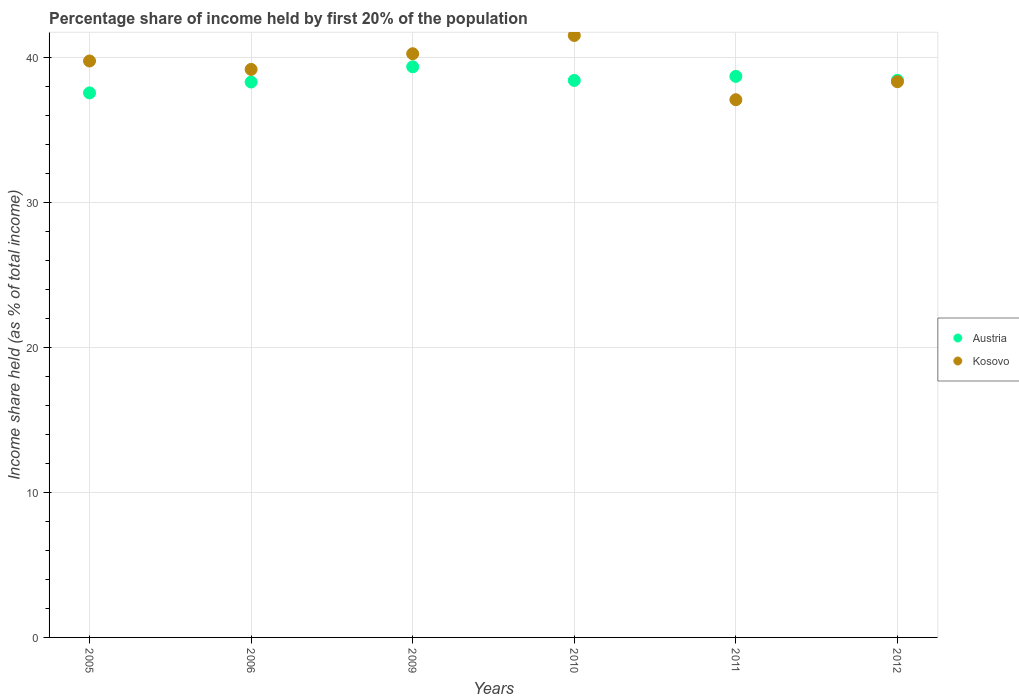Is the number of dotlines equal to the number of legend labels?
Make the answer very short. Yes. What is the share of income held by first 20% of the population in Austria in 2010?
Offer a terse response. 38.4. Across all years, what is the maximum share of income held by first 20% of the population in Kosovo?
Your answer should be compact. 41.5. Across all years, what is the minimum share of income held by first 20% of the population in Austria?
Your answer should be compact. 37.54. In which year was the share of income held by first 20% of the population in Austria maximum?
Give a very brief answer. 2009. In which year was the share of income held by first 20% of the population in Kosovo minimum?
Your response must be concise. 2011. What is the total share of income held by first 20% of the population in Kosovo in the graph?
Offer a very short reply. 236.02. What is the difference between the share of income held by first 20% of the population in Austria in 2006 and that in 2012?
Make the answer very short. -0.12. What is the difference between the share of income held by first 20% of the population in Kosovo in 2009 and the share of income held by first 20% of the population in Austria in 2012?
Make the answer very short. 1.83. What is the average share of income held by first 20% of the population in Austria per year?
Keep it short and to the point. 38.44. In the year 2005, what is the difference between the share of income held by first 20% of the population in Kosovo and share of income held by first 20% of the population in Austria?
Make the answer very short. 2.2. What is the ratio of the share of income held by first 20% of the population in Kosovo in 2005 to that in 2012?
Your answer should be very brief. 1.04. Is the share of income held by first 20% of the population in Austria in 2005 less than that in 2011?
Offer a terse response. Yes. What is the difference between the highest and the second highest share of income held by first 20% of the population in Kosovo?
Offer a very short reply. 1.26. What is the difference between the highest and the lowest share of income held by first 20% of the population in Kosovo?
Your answer should be very brief. 4.43. Is the sum of the share of income held by first 20% of the population in Kosovo in 2009 and 2011 greater than the maximum share of income held by first 20% of the population in Austria across all years?
Provide a succinct answer. Yes. Is the share of income held by first 20% of the population in Austria strictly greater than the share of income held by first 20% of the population in Kosovo over the years?
Your response must be concise. No. Is the share of income held by first 20% of the population in Kosovo strictly less than the share of income held by first 20% of the population in Austria over the years?
Provide a short and direct response. No. How many dotlines are there?
Ensure brevity in your answer.  2. Where does the legend appear in the graph?
Provide a short and direct response. Center right. How are the legend labels stacked?
Offer a terse response. Vertical. What is the title of the graph?
Offer a terse response. Percentage share of income held by first 20% of the population. Does "South Asia" appear as one of the legend labels in the graph?
Offer a very short reply. No. What is the label or title of the Y-axis?
Offer a terse response. Income share held (as % of total income). What is the Income share held (as % of total income) in Austria in 2005?
Make the answer very short. 37.54. What is the Income share held (as % of total income) of Kosovo in 2005?
Your answer should be very brief. 39.74. What is the Income share held (as % of total income) of Austria in 2006?
Your answer should be very brief. 38.29. What is the Income share held (as % of total income) in Kosovo in 2006?
Provide a short and direct response. 39.16. What is the Income share held (as % of total income) of Austria in 2009?
Provide a short and direct response. 39.34. What is the Income share held (as % of total income) in Kosovo in 2009?
Offer a terse response. 40.24. What is the Income share held (as % of total income) of Austria in 2010?
Provide a short and direct response. 38.4. What is the Income share held (as % of total income) in Kosovo in 2010?
Your response must be concise. 41.5. What is the Income share held (as % of total income) of Austria in 2011?
Make the answer very short. 38.68. What is the Income share held (as % of total income) of Kosovo in 2011?
Ensure brevity in your answer.  37.07. What is the Income share held (as % of total income) of Austria in 2012?
Offer a terse response. 38.41. What is the Income share held (as % of total income) of Kosovo in 2012?
Keep it short and to the point. 38.31. Across all years, what is the maximum Income share held (as % of total income) in Austria?
Provide a short and direct response. 39.34. Across all years, what is the maximum Income share held (as % of total income) in Kosovo?
Offer a very short reply. 41.5. Across all years, what is the minimum Income share held (as % of total income) of Austria?
Make the answer very short. 37.54. Across all years, what is the minimum Income share held (as % of total income) of Kosovo?
Your response must be concise. 37.07. What is the total Income share held (as % of total income) in Austria in the graph?
Offer a terse response. 230.66. What is the total Income share held (as % of total income) of Kosovo in the graph?
Offer a very short reply. 236.02. What is the difference between the Income share held (as % of total income) in Austria in 2005 and that in 2006?
Ensure brevity in your answer.  -0.75. What is the difference between the Income share held (as % of total income) of Kosovo in 2005 and that in 2006?
Offer a terse response. 0.58. What is the difference between the Income share held (as % of total income) in Austria in 2005 and that in 2009?
Keep it short and to the point. -1.8. What is the difference between the Income share held (as % of total income) of Austria in 2005 and that in 2010?
Your answer should be compact. -0.86. What is the difference between the Income share held (as % of total income) of Kosovo in 2005 and that in 2010?
Your answer should be compact. -1.76. What is the difference between the Income share held (as % of total income) in Austria in 2005 and that in 2011?
Keep it short and to the point. -1.14. What is the difference between the Income share held (as % of total income) in Kosovo in 2005 and that in 2011?
Provide a short and direct response. 2.67. What is the difference between the Income share held (as % of total income) in Austria in 2005 and that in 2012?
Provide a short and direct response. -0.87. What is the difference between the Income share held (as % of total income) in Kosovo in 2005 and that in 2012?
Your answer should be very brief. 1.43. What is the difference between the Income share held (as % of total income) in Austria in 2006 and that in 2009?
Make the answer very short. -1.05. What is the difference between the Income share held (as % of total income) in Kosovo in 2006 and that in 2009?
Keep it short and to the point. -1.08. What is the difference between the Income share held (as % of total income) of Austria in 2006 and that in 2010?
Offer a very short reply. -0.11. What is the difference between the Income share held (as % of total income) of Kosovo in 2006 and that in 2010?
Your answer should be compact. -2.34. What is the difference between the Income share held (as % of total income) in Austria in 2006 and that in 2011?
Offer a very short reply. -0.39. What is the difference between the Income share held (as % of total income) in Kosovo in 2006 and that in 2011?
Ensure brevity in your answer.  2.09. What is the difference between the Income share held (as % of total income) of Austria in 2006 and that in 2012?
Your answer should be very brief. -0.12. What is the difference between the Income share held (as % of total income) of Austria in 2009 and that in 2010?
Provide a succinct answer. 0.94. What is the difference between the Income share held (as % of total income) in Kosovo in 2009 and that in 2010?
Provide a succinct answer. -1.26. What is the difference between the Income share held (as % of total income) in Austria in 2009 and that in 2011?
Offer a terse response. 0.66. What is the difference between the Income share held (as % of total income) of Kosovo in 2009 and that in 2011?
Offer a very short reply. 3.17. What is the difference between the Income share held (as % of total income) of Kosovo in 2009 and that in 2012?
Give a very brief answer. 1.93. What is the difference between the Income share held (as % of total income) in Austria in 2010 and that in 2011?
Provide a succinct answer. -0.28. What is the difference between the Income share held (as % of total income) of Kosovo in 2010 and that in 2011?
Make the answer very short. 4.43. What is the difference between the Income share held (as % of total income) in Austria in 2010 and that in 2012?
Provide a short and direct response. -0.01. What is the difference between the Income share held (as % of total income) in Kosovo in 2010 and that in 2012?
Your answer should be very brief. 3.19. What is the difference between the Income share held (as % of total income) in Austria in 2011 and that in 2012?
Provide a short and direct response. 0.27. What is the difference between the Income share held (as % of total income) of Kosovo in 2011 and that in 2012?
Your answer should be very brief. -1.24. What is the difference between the Income share held (as % of total income) of Austria in 2005 and the Income share held (as % of total income) of Kosovo in 2006?
Offer a very short reply. -1.62. What is the difference between the Income share held (as % of total income) in Austria in 2005 and the Income share held (as % of total income) in Kosovo in 2009?
Your response must be concise. -2.7. What is the difference between the Income share held (as % of total income) in Austria in 2005 and the Income share held (as % of total income) in Kosovo in 2010?
Offer a very short reply. -3.96. What is the difference between the Income share held (as % of total income) in Austria in 2005 and the Income share held (as % of total income) in Kosovo in 2011?
Ensure brevity in your answer.  0.47. What is the difference between the Income share held (as % of total income) of Austria in 2005 and the Income share held (as % of total income) of Kosovo in 2012?
Offer a very short reply. -0.77. What is the difference between the Income share held (as % of total income) in Austria in 2006 and the Income share held (as % of total income) in Kosovo in 2009?
Offer a terse response. -1.95. What is the difference between the Income share held (as % of total income) of Austria in 2006 and the Income share held (as % of total income) of Kosovo in 2010?
Your response must be concise. -3.21. What is the difference between the Income share held (as % of total income) in Austria in 2006 and the Income share held (as % of total income) in Kosovo in 2011?
Give a very brief answer. 1.22. What is the difference between the Income share held (as % of total income) of Austria in 2006 and the Income share held (as % of total income) of Kosovo in 2012?
Ensure brevity in your answer.  -0.02. What is the difference between the Income share held (as % of total income) of Austria in 2009 and the Income share held (as % of total income) of Kosovo in 2010?
Offer a very short reply. -2.16. What is the difference between the Income share held (as % of total income) in Austria in 2009 and the Income share held (as % of total income) in Kosovo in 2011?
Offer a very short reply. 2.27. What is the difference between the Income share held (as % of total income) of Austria in 2010 and the Income share held (as % of total income) of Kosovo in 2011?
Your answer should be very brief. 1.33. What is the difference between the Income share held (as % of total income) in Austria in 2010 and the Income share held (as % of total income) in Kosovo in 2012?
Offer a very short reply. 0.09. What is the difference between the Income share held (as % of total income) in Austria in 2011 and the Income share held (as % of total income) in Kosovo in 2012?
Offer a terse response. 0.37. What is the average Income share held (as % of total income) in Austria per year?
Your answer should be very brief. 38.44. What is the average Income share held (as % of total income) of Kosovo per year?
Ensure brevity in your answer.  39.34. In the year 2006, what is the difference between the Income share held (as % of total income) of Austria and Income share held (as % of total income) of Kosovo?
Provide a succinct answer. -0.87. In the year 2011, what is the difference between the Income share held (as % of total income) in Austria and Income share held (as % of total income) in Kosovo?
Make the answer very short. 1.61. What is the ratio of the Income share held (as % of total income) in Austria in 2005 to that in 2006?
Provide a short and direct response. 0.98. What is the ratio of the Income share held (as % of total income) of Kosovo in 2005 to that in 2006?
Make the answer very short. 1.01. What is the ratio of the Income share held (as % of total income) in Austria in 2005 to that in 2009?
Provide a succinct answer. 0.95. What is the ratio of the Income share held (as % of total income) in Kosovo in 2005 to that in 2009?
Your answer should be compact. 0.99. What is the ratio of the Income share held (as % of total income) in Austria in 2005 to that in 2010?
Provide a short and direct response. 0.98. What is the ratio of the Income share held (as % of total income) of Kosovo in 2005 to that in 2010?
Offer a terse response. 0.96. What is the ratio of the Income share held (as % of total income) of Austria in 2005 to that in 2011?
Make the answer very short. 0.97. What is the ratio of the Income share held (as % of total income) of Kosovo in 2005 to that in 2011?
Give a very brief answer. 1.07. What is the ratio of the Income share held (as % of total income) in Austria in 2005 to that in 2012?
Provide a succinct answer. 0.98. What is the ratio of the Income share held (as % of total income) in Kosovo in 2005 to that in 2012?
Make the answer very short. 1.04. What is the ratio of the Income share held (as % of total income) of Austria in 2006 to that in 2009?
Give a very brief answer. 0.97. What is the ratio of the Income share held (as % of total income) of Kosovo in 2006 to that in 2009?
Give a very brief answer. 0.97. What is the ratio of the Income share held (as % of total income) in Kosovo in 2006 to that in 2010?
Your answer should be compact. 0.94. What is the ratio of the Income share held (as % of total income) of Kosovo in 2006 to that in 2011?
Offer a terse response. 1.06. What is the ratio of the Income share held (as % of total income) in Kosovo in 2006 to that in 2012?
Give a very brief answer. 1.02. What is the ratio of the Income share held (as % of total income) in Austria in 2009 to that in 2010?
Your answer should be very brief. 1.02. What is the ratio of the Income share held (as % of total income) in Kosovo in 2009 to that in 2010?
Keep it short and to the point. 0.97. What is the ratio of the Income share held (as % of total income) of Austria in 2009 to that in 2011?
Ensure brevity in your answer.  1.02. What is the ratio of the Income share held (as % of total income) in Kosovo in 2009 to that in 2011?
Offer a terse response. 1.09. What is the ratio of the Income share held (as % of total income) of Austria in 2009 to that in 2012?
Make the answer very short. 1.02. What is the ratio of the Income share held (as % of total income) of Kosovo in 2009 to that in 2012?
Your answer should be compact. 1.05. What is the ratio of the Income share held (as % of total income) of Austria in 2010 to that in 2011?
Your answer should be compact. 0.99. What is the ratio of the Income share held (as % of total income) of Kosovo in 2010 to that in 2011?
Make the answer very short. 1.12. What is the ratio of the Income share held (as % of total income) in Austria in 2010 to that in 2012?
Ensure brevity in your answer.  1. What is the ratio of the Income share held (as % of total income) in Kosovo in 2011 to that in 2012?
Give a very brief answer. 0.97. What is the difference between the highest and the second highest Income share held (as % of total income) in Austria?
Provide a short and direct response. 0.66. What is the difference between the highest and the second highest Income share held (as % of total income) in Kosovo?
Offer a very short reply. 1.26. What is the difference between the highest and the lowest Income share held (as % of total income) of Kosovo?
Make the answer very short. 4.43. 